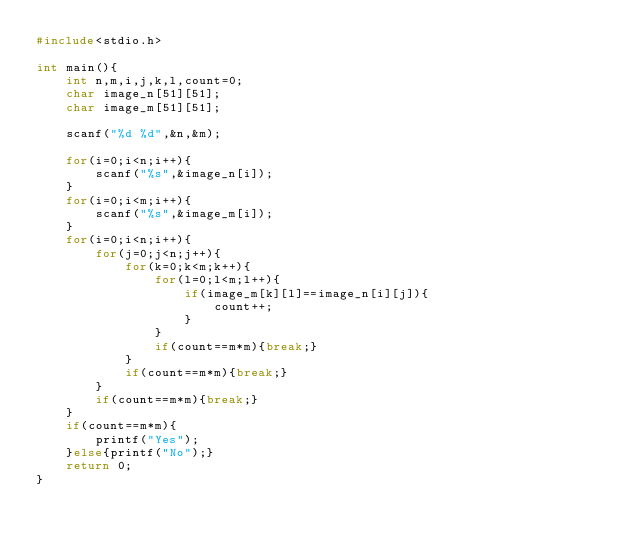<code> <loc_0><loc_0><loc_500><loc_500><_C_>#include<stdio.h>

int main(){
    int n,m,i,j,k,l,count=0;
    char image_n[51][51];
    char image_m[51][51];

    scanf("%d %d",&n,&m);

    for(i=0;i<n;i++){
        scanf("%s",&image_n[i]);    
    }
    for(i=0;i<m;i++){
        scanf("%s",&image_m[i]);
    }
    for(i=0;i<n;i++){
        for(j=0;j<n;j++){
            for(k=0;k<m;k++){
                for(l=0;l<m;l++){
                    if(image_m[k][l]==image_n[i][j]){
                        count++;
                    }
                }
                if(count==m*m){break;}
            }
            if(count==m*m){break;}
        }
        if(count==m*m){break;}
    }
    if(count==m*m){
        printf("Yes");
    }else{printf("No");}
    return 0;
}</code> 